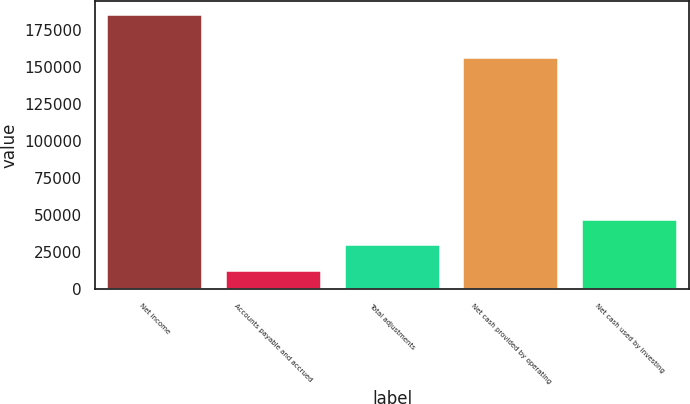Convert chart. <chart><loc_0><loc_0><loc_500><loc_500><bar_chart><fcel>Net income<fcel>Accounts payable and accrued<fcel>Total adjustments<fcel>Net cash provided by operating<fcel>Net cash used by investing<nl><fcel>185000<fcel>12380<fcel>29642<fcel>156135<fcel>46904<nl></chart> 